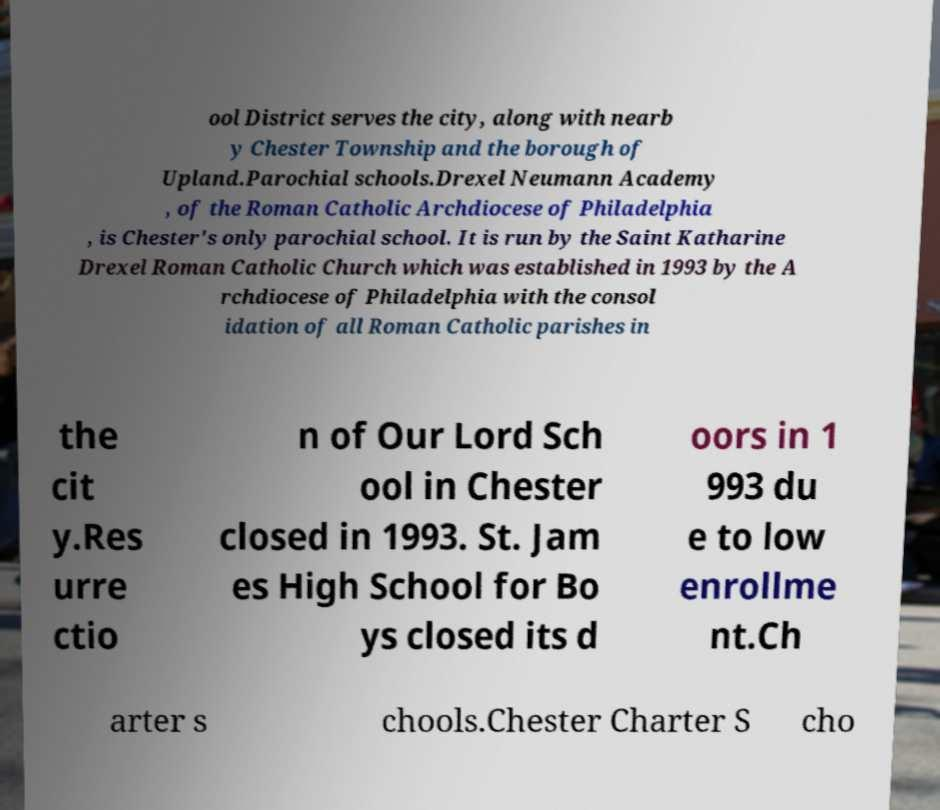Can you accurately transcribe the text from the provided image for me? ool District serves the city, along with nearb y Chester Township and the borough of Upland.Parochial schools.Drexel Neumann Academy , of the Roman Catholic Archdiocese of Philadelphia , is Chester's only parochial school. It is run by the Saint Katharine Drexel Roman Catholic Church which was established in 1993 by the A rchdiocese of Philadelphia with the consol idation of all Roman Catholic parishes in the cit y.Res urre ctio n of Our Lord Sch ool in Chester closed in 1993. St. Jam es High School for Bo ys closed its d oors in 1 993 du e to low enrollme nt.Ch arter s chools.Chester Charter S cho 